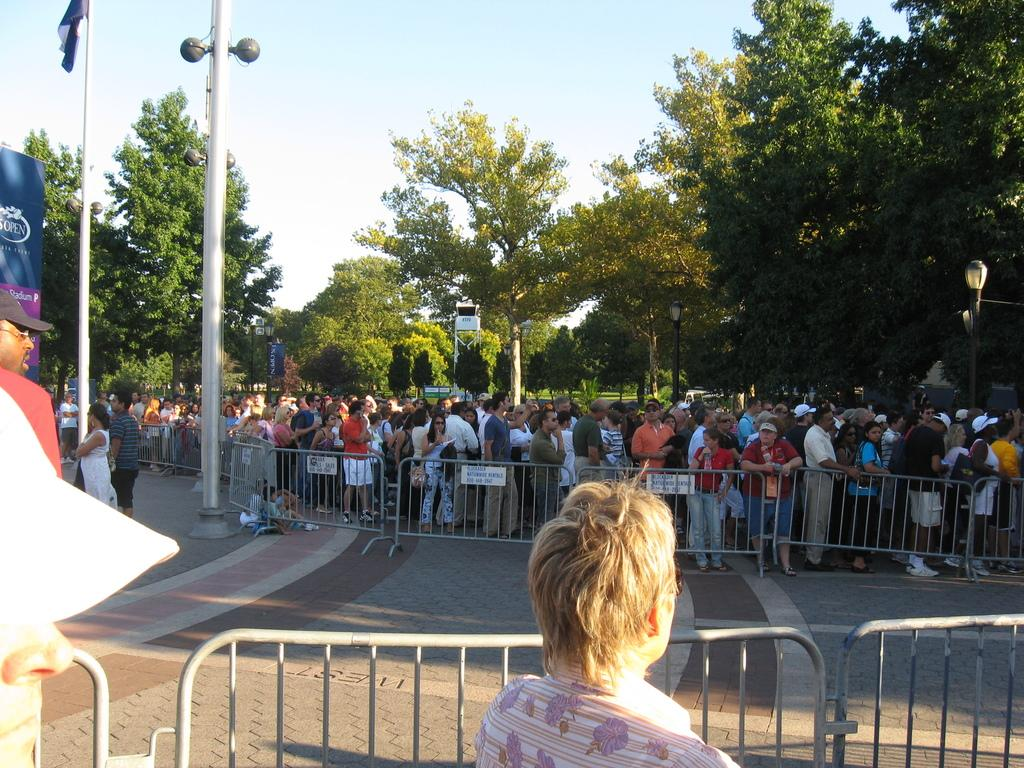What objects are present in the image that might be used to control or direct traffic? In the image, there are barriers and poles that might be used to control or direct traffic. What objects are present in the image that might be used for displaying information or advertisements? In the image, there are boards that might be used for displaying information or advertisements. What is the group of people in the image doing? The group of people in the image is standing, but their specific activity is not clear from the provided facts. What objects are present in the image that might be used for illumination? In the image, there are lights that might be used for illumination. What objects are present in the image that might be used as a symbol of a country or organization? In the image, there is a flag that might be used as a symbol of a country or organization. What type of natural vegetation is visible in the image? In the image, there are trees that represent natural vegetation. What can be seen in the background of the image? In the background of the image, the sky is visible. Can you see a roof in the image? There is no mention of a roof in the provided facts, so it cannot be determined if one is present in the image. Are the people in the image kissing? There is no indication in the provided facts that the people in the image are kissing. 